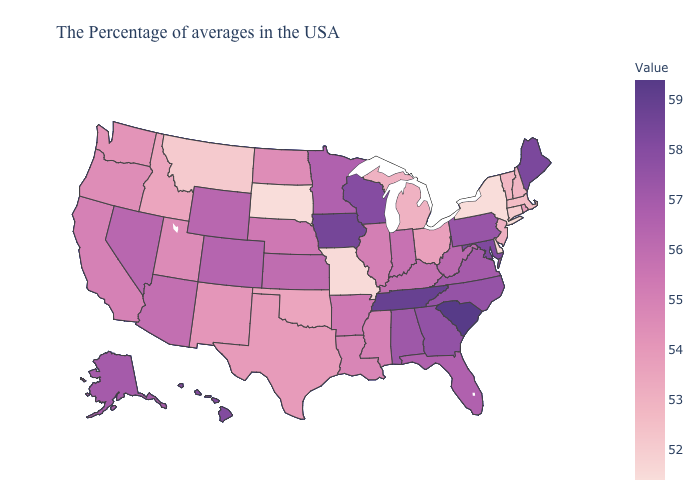Does Oklahoma have a lower value than Iowa?
Be succinct. Yes. Among the states that border Pennsylvania , does New Jersey have the lowest value?
Answer briefly. No. Which states have the lowest value in the Northeast?
Be succinct. New York. Which states hav the highest value in the South?
Concise answer only. South Carolina. Does South Carolina have the highest value in the USA?
Quick response, please. Yes. Does Michigan have the lowest value in the MidWest?
Answer briefly. No. Does South Dakota have the lowest value in the USA?
Short answer required. Yes. 